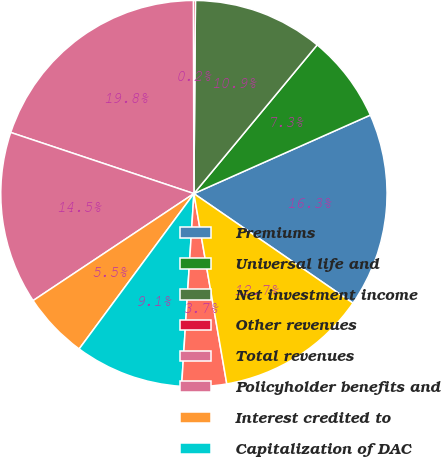<chart> <loc_0><loc_0><loc_500><loc_500><pie_chart><fcel>Premiums<fcel>Universal life and<fcel>Net investment income<fcel>Other revenues<fcel>Total revenues<fcel>Policyholder benefits and<fcel>Interest credited to<fcel>Capitalization of DAC<fcel>Amortization of DAC and VOBA<fcel>Other expenses<nl><fcel>16.26%<fcel>7.32%<fcel>10.89%<fcel>0.17%<fcel>19.83%<fcel>14.47%<fcel>5.53%<fcel>9.11%<fcel>3.74%<fcel>12.68%<nl></chart> 